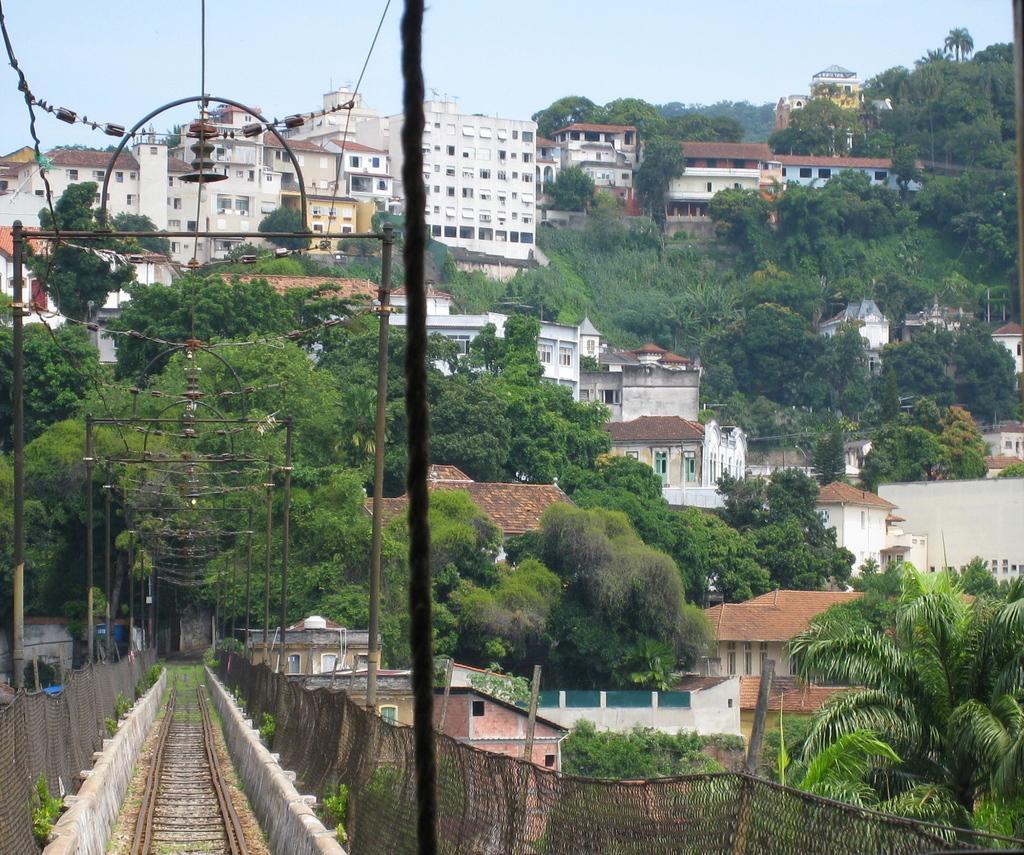Can you describe this image briefly? On the left side of the image we can see railway track and current polls. On the left side we can see buildings and trees. In the background there are buildings, trees, plants and sky. 